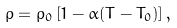Convert formula to latex. <formula><loc_0><loc_0><loc_500><loc_500>\rho = \rho _ { 0 } \left [ 1 - \alpha ( T - T _ { 0 } ) \right ] ,</formula> 